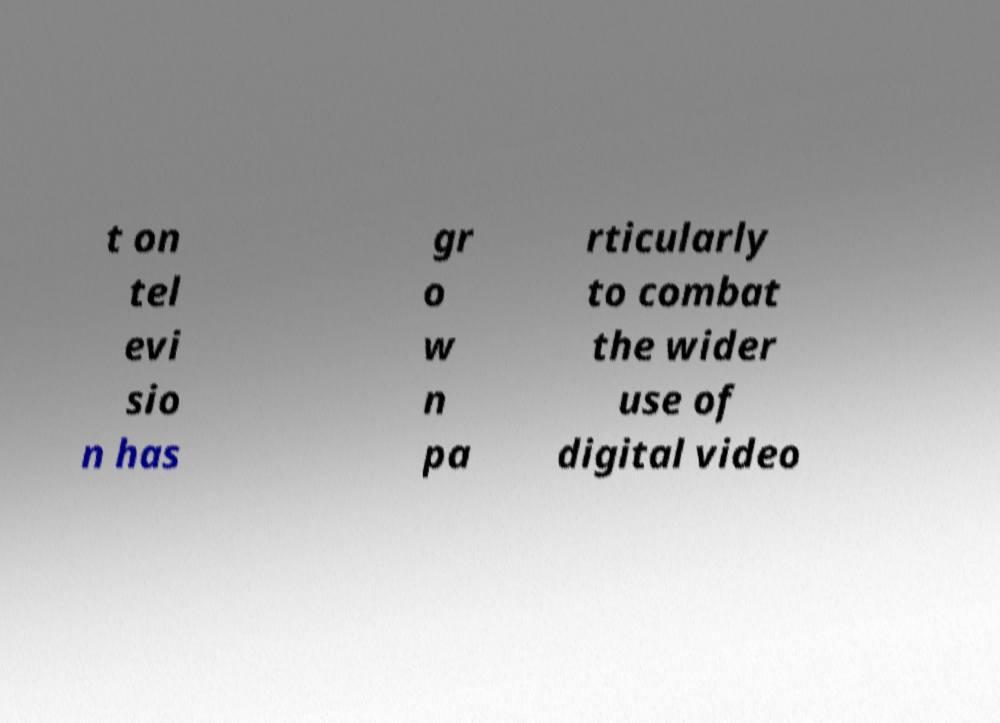Can you accurately transcribe the text from the provided image for me? t on tel evi sio n has gr o w n pa rticularly to combat the wider use of digital video 